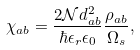Convert formula to latex. <formula><loc_0><loc_0><loc_500><loc_500>\chi _ { a b } = \frac { 2 \mathcal { N } d _ { a b } ^ { 2 } } { \hbar { \epsilon } _ { r } \epsilon _ { 0 } } \frac { \rho _ { a b } } { \Omega _ { s } } ,</formula> 